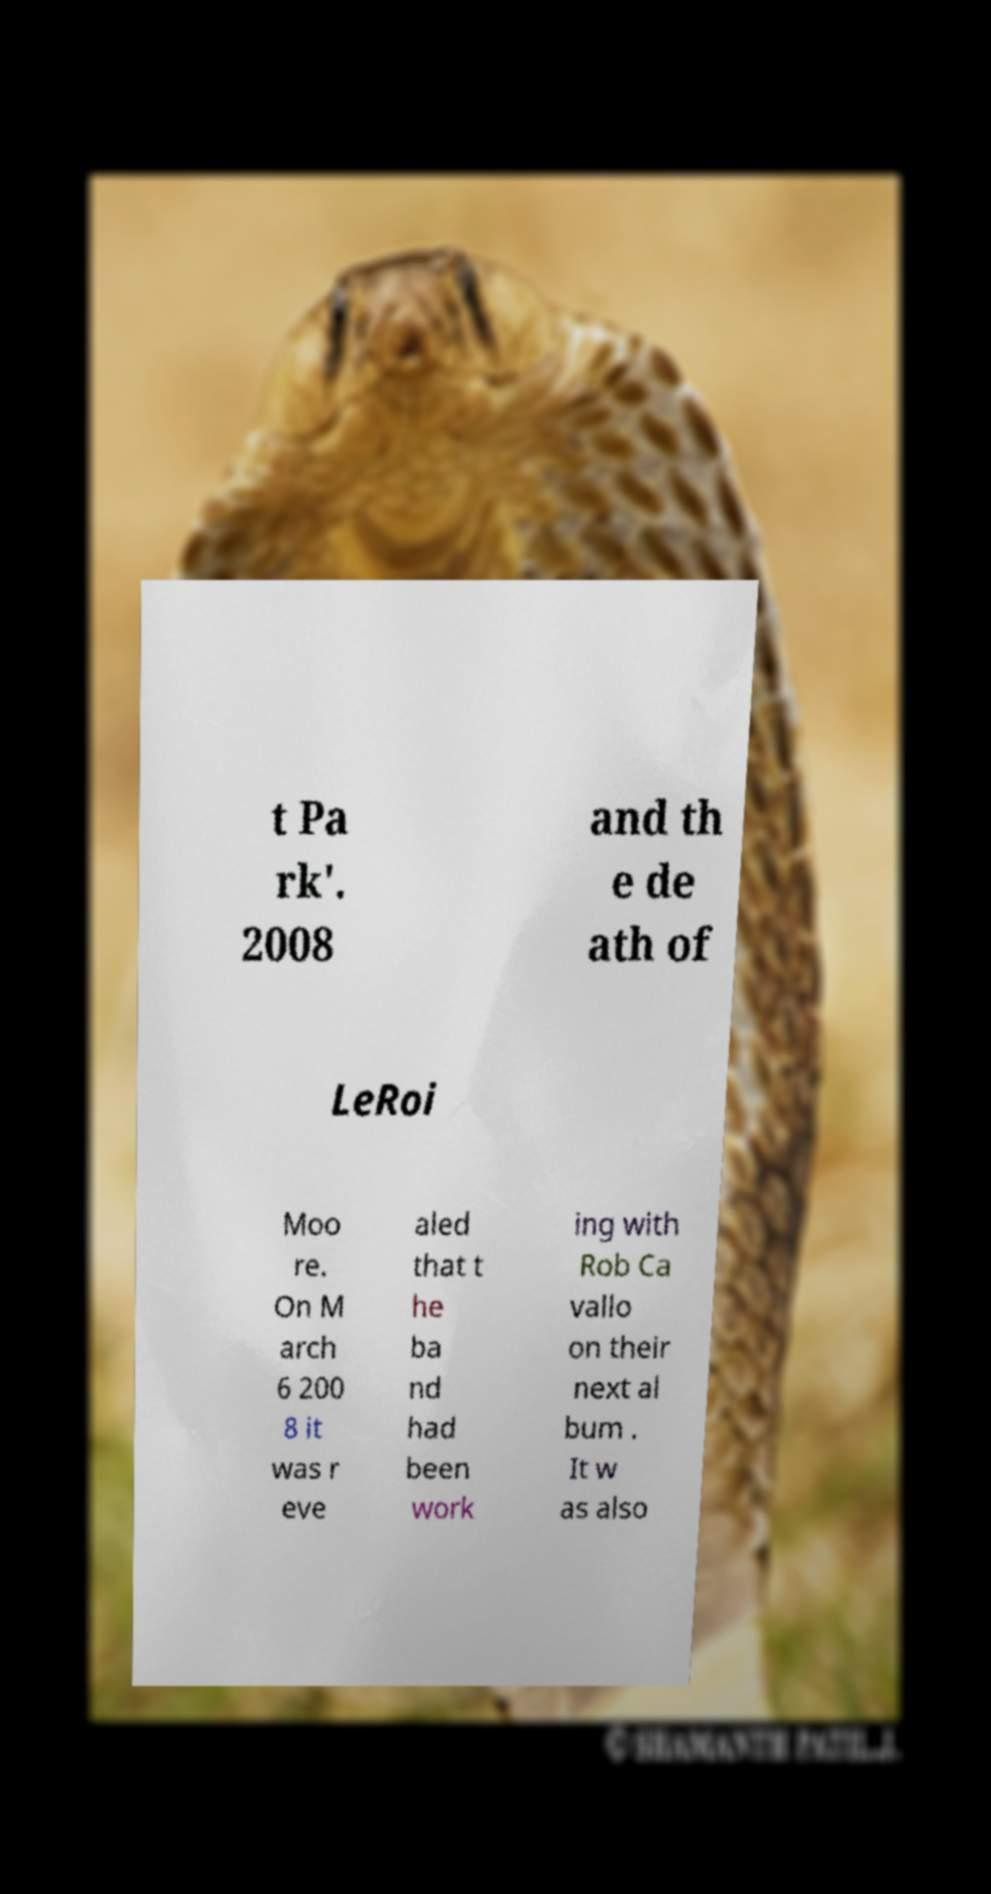Please identify and transcribe the text found in this image. t Pa rk'. 2008 and th e de ath of LeRoi Moo re. On M arch 6 200 8 it was r eve aled that t he ba nd had been work ing with Rob Ca vallo on their next al bum . It w as also 